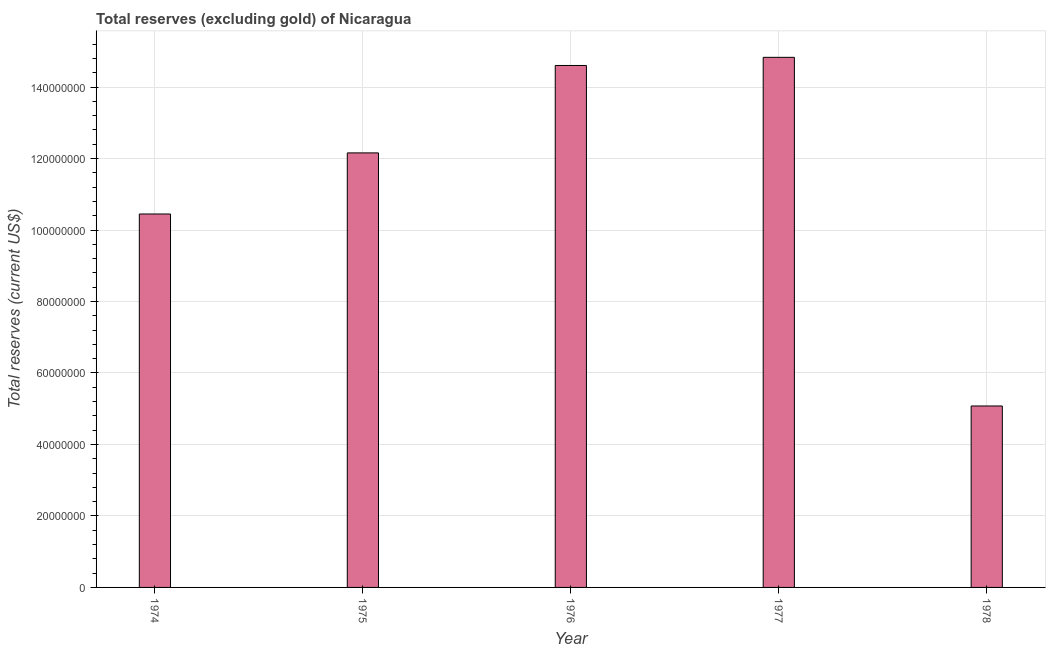What is the title of the graph?
Your response must be concise. Total reserves (excluding gold) of Nicaragua. What is the label or title of the X-axis?
Provide a short and direct response. Year. What is the label or title of the Y-axis?
Ensure brevity in your answer.  Total reserves (current US$). What is the total reserves (excluding gold) in 1978?
Your response must be concise. 5.08e+07. Across all years, what is the maximum total reserves (excluding gold)?
Give a very brief answer. 1.48e+08. Across all years, what is the minimum total reserves (excluding gold)?
Make the answer very short. 5.08e+07. In which year was the total reserves (excluding gold) maximum?
Provide a short and direct response. 1977. In which year was the total reserves (excluding gold) minimum?
Provide a succinct answer. 1978. What is the sum of the total reserves (excluding gold)?
Ensure brevity in your answer.  5.71e+08. What is the difference between the total reserves (excluding gold) in 1976 and 1977?
Your answer should be very brief. -2.28e+06. What is the average total reserves (excluding gold) per year?
Your answer should be very brief. 1.14e+08. What is the median total reserves (excluding gold)?
Give a very brief answer. 1.22e+08. Do a majority of the years between 1977 and 1975 (inclusive) have total reserves (excluding gold) greater than 36000000 US$?
Ensure brevity in your answer.  Yes. What is the ratio of the total reserves (excluding gold) in 1975 to that in 1978?
Give a very brief answer. 2.4. What is the difference between the highest and the second highest total reserves (excluding gold)?
Your response must be concise. 2.28e+06. Is the sum of the total reserves (excluding gold) in 1975 and 1978 greater than the maximum total reserves (excluding gold) across all years?
Your answer should be compact. Yes. What is the difference between the highest and the lowest total reserves (excluding gold)?
Provide a short and direct response. 9.76e+07. In how many years, is the total reserves (excluding gold) greater than the average total reserves (excluding gold) taken over all years?
Offer a very short reply. 3. How many bars are there?
Offer a terse response. 5. Are all the bars in the graph horizontal?
Ensure brevity in your answer.  No. What is the difference between two consecutive major ticks on the Y-axis?
Offer a very short reply. 2.00e+07. Are the values on the major ticks of Y-axis written in scientific E-notation?
Your answer should be very brief. No. What is the Total reserves (current US$) of 1974?
Make the answer very short. 1.04e+08. What is the Total reserves (current US$) in 1975?
Make the answer very short. 1.22e+08. What is the Total reserves (current US$) in 1976?
Your response must be concise. 1.46e+08. What is the Total reserves (current US$) of 1977?
Offer a terse response. 1.48e+08. What is the Total reserves (current US$) of 1978?
Ensure brevity in your answer.  5.08e+07. What is the difference between the Total reserves (current US$) in 1974 and 1975?
Your answer should be compact. -1.71e+07. What is the difference between the Total reserves (current US$) in 1974 and 1976?
Your answer should be very brief. -4.16e+07. What is the difference between the Total reserves (current US$) in 1974 and 1977?
Offer a terse response. -4.38e+07. What is the difference between the Total reserves (current US$) in 1974 and 1978?
Give a very brief answer. 5.37e+07. What is the difference between the Total reserves (current US$) in 1975 and 1976?
Ensure brevity in your answer.  -2.45e+07. What is the difference between the Total reserves (current US$) in 1975 and 1977?
Offer a terse response. -2.67e+07. What is the difference between the Total reserves (current US$) in 1975 and 1978?
Keep it short and to the point. 7.08e+07. What is the difference between the Total reserves (current US$) in 1976 and 1977?
Provide a succinct answer. -2.28e+06. What is the difference between the Total reserves (current US$) in 1976 and 1978?
Provide a succinct answer. 9.53e+07. What is the difference between the Total reserves (current US$) in 1977 and 1978?
Keep it short and to the point. 9.76e+07. What is the ratio of the Total reserves (current US$) in 1974 to that in 1975?
Make the answer very short. 0.86. What is the ratio of the Total reserves (current US$) in 1974 to that in 1976?
Keep it short and to the point. 0.71. What is the ratio of the Total reserves (current US$) in 1974 to that in 1977?
Keep it short and to the point. 0.7. What is the ratio of the Total reserves (current US$) in 1974 to that in 1978?
Provide a short and direct response. 2.06. What is the ratio of the Total reserves (current US$) in 1975 to that in 1976?
Your answer should be compact. 0.83. What is the ratio of the Total reserves (current US$) in 1975 to that in 1977?
Your answer should be compact. 0.82. What is the ratio of the Total reserves (current US$) in 1975 to that in 1978?
Offer a terse response. 2.4. What is the ratio of the Total reserves (current US$) in 1976 to that in 1977?
Offer a terse response. 0.98. What is the ratio of the Total reserves (current US$) in 1976 to that in 1978?
Provide a short and direct response. 2.88. What is the ratio of the Total reserves (current US$) in 1977 to that in 1978?
Your response must be concise. 2.92. 